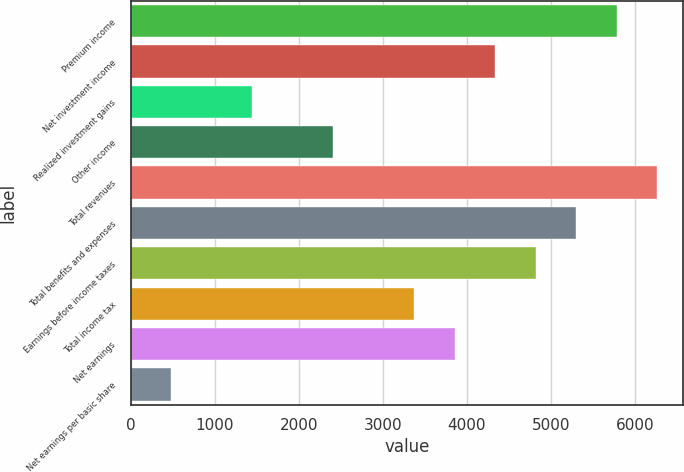Convert chart. <chart><loc_0><loc_0><loc_500><loc_500><bar_chart><fcel>Premium income<fcel>Net investment income<fcel>Realized investment gains<fcel>Other income<fcel>Total revenues<fcel>Total benefits and expenses<fcel>Earnings before income taxes<fcel>Total income tax<fcel>Net earnings<fcel>Net earnings per basic share<nl><fcel>5781.52<fcel>4336.21<fcel>1445.59<fcel>2409.13<fcel>6263.29<fcel>5299.75<fcel>4817.98<fcel>3372.67<fcel>3854.44<fcel>482.05<nl></chart> 